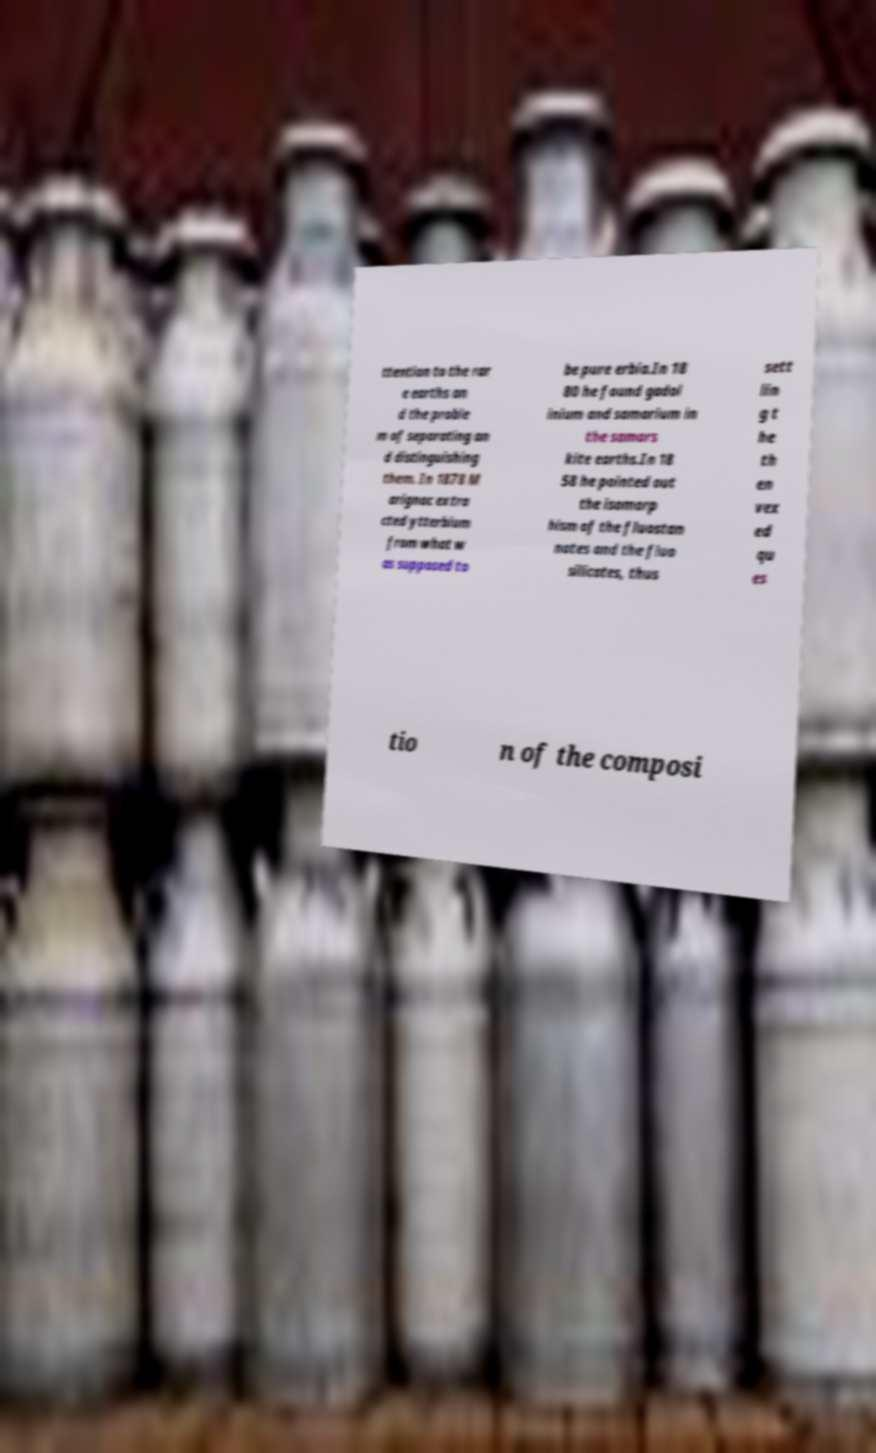Could you assist in decoding the text presented in this image and type it out clearly? ttention to the rar e earths an d the proble m of separating an d distinguishing them. In 1878 M arignac extra cted ytterbium from what w as supposed to be pure erbia.In 18 80 he found gadol inium and samarium in the samars kite earths.In 18 58 he pointed out the isomorp hism of the fluostan nates and the fluo silicates, thus sett lin g t he th en vex ed qu es tio n of the composi 